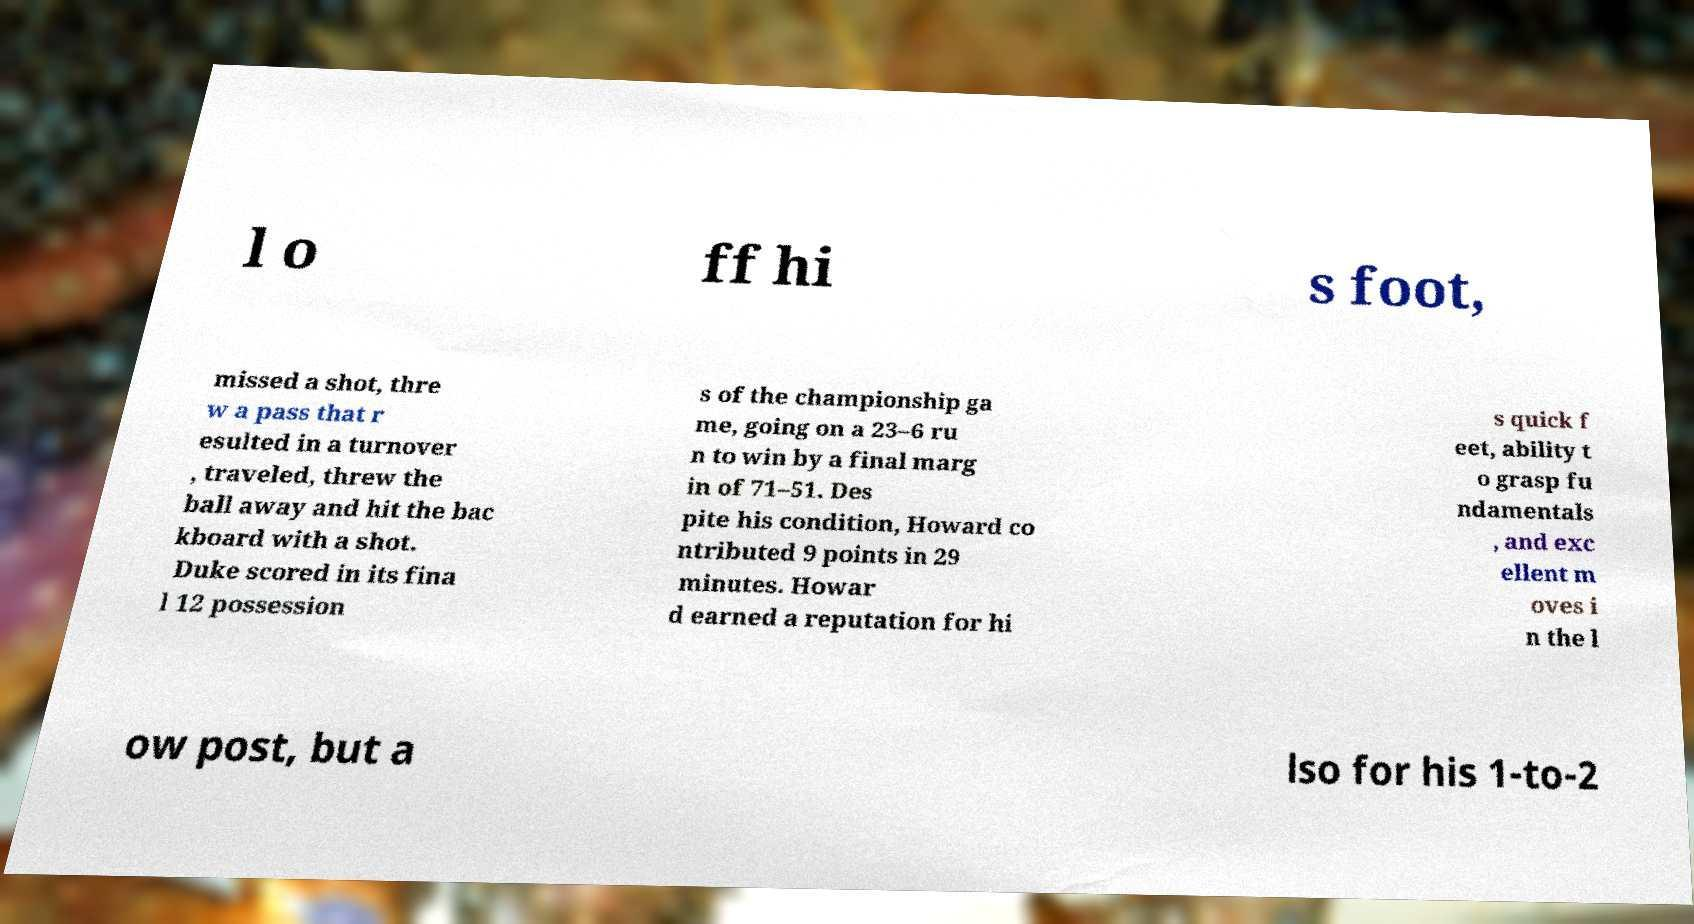For documentation purposes, I need the text within this image transcribed. Could you provide that? l o ff hi s foot, missed a shot, thre w a pass that r esulted in a turnover , traveled, threw the ball away and hit the bac kboard with a shot. Duke scored in its fina l 12 possession s of the championship ga me, going on a 23–6 ru n to win by a final marg in of 71–51. Des pite his condition, Howard co ntributed 9 points in 29 minutes. Howar d earned a reputation for hi s quick f eet, ability t o grasp fu ndamentals , and exc ellent m oves i n the l ow post, but a lso for his 1-to-2 